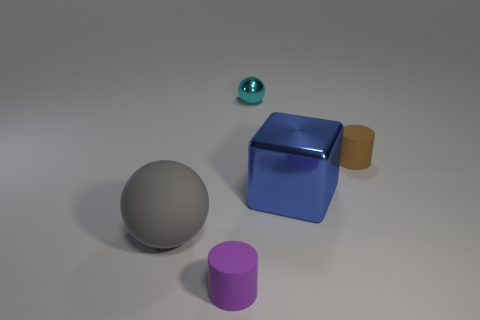Is the color of the small cylinder that is to the right of the small metallic object the same as the small rubber cylinder to the left of the cyan object?
Make the answer very short. No. How many big things are either purple spheres or gray rubber balls?
Offer a very short reply. 1. The other rubber thing that is the same shape as the small cyan thing is what size?
Offer a very short reply. Large. What is the material of the thing that is behind the tiny cylinder on the right side of the tiny purple object?
Provide a succinct answer. Metal. How many metallic things are either brown cylinders or cyan balls?
Provide a succinct answer. 1. The other small thing that is the same shape as the gray object is what color?
Your answer should be very brief. Cyan. What number of shiny objects are the same color as the large ball?
Give a very brief answer. 0. Is there a small brown object on the right side of the tiny brown cylinder behind the large gray rubber object?
Offer a very short reply. No. How many objects are both in front of the cyan metal ball and behind the large shiny object?
Your answer should be very brief. 1. What number of big gray blocks have the same material as the small purple thing?
Ensure brevity in your answer.  0. 